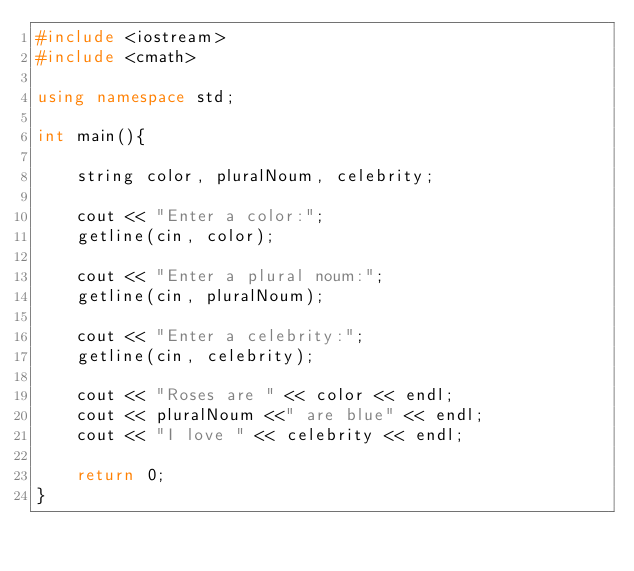<code> <loc_0><loc_0><loc_500><loc_500><_C++_>#include <iostream>
#include <cmath>

using namespace std;

int main(){

    string color, pluralNoum, celebrity;

    cout << "Enter a color:";
    getline(cin, color);

    cout << "Enter a plural noum:";
    getline(cin, pluralNoum);

    cout << "Enter a celebrity:";
    getline(cin, celebrity);

    cout << "Roses are " << color << endl;
    cout << pluralNoum <<" are blue" << endl;
    cout << "I love " << celebrity << endl;

    return 0;
}</code> 